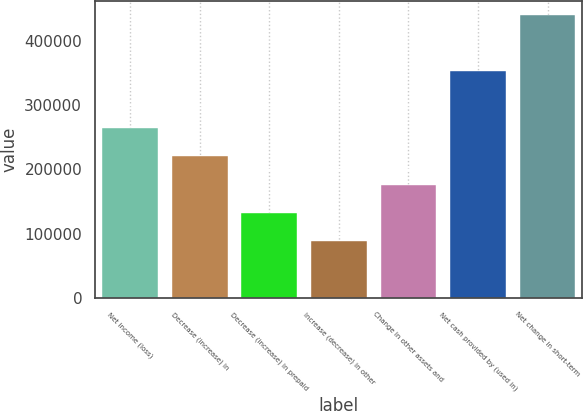<chart> <loc_0><loc_0><loc_500><loc_500><bar_chart><fcel>Net income (loss)<fcel>Decrease (increase) in<fcel>Decrease (increase) in prepaid<fcel>Increase (decrease) in other<fcel>Change in other assets and<fcel>Net cash provided by (used in)<fcel>Net change in short-term<nl><fcel>264461<fcel>220417<fcel>132329<fcel>88285.6<fcel>176373<fcel>352548<fcel>440636<nl></chart> 